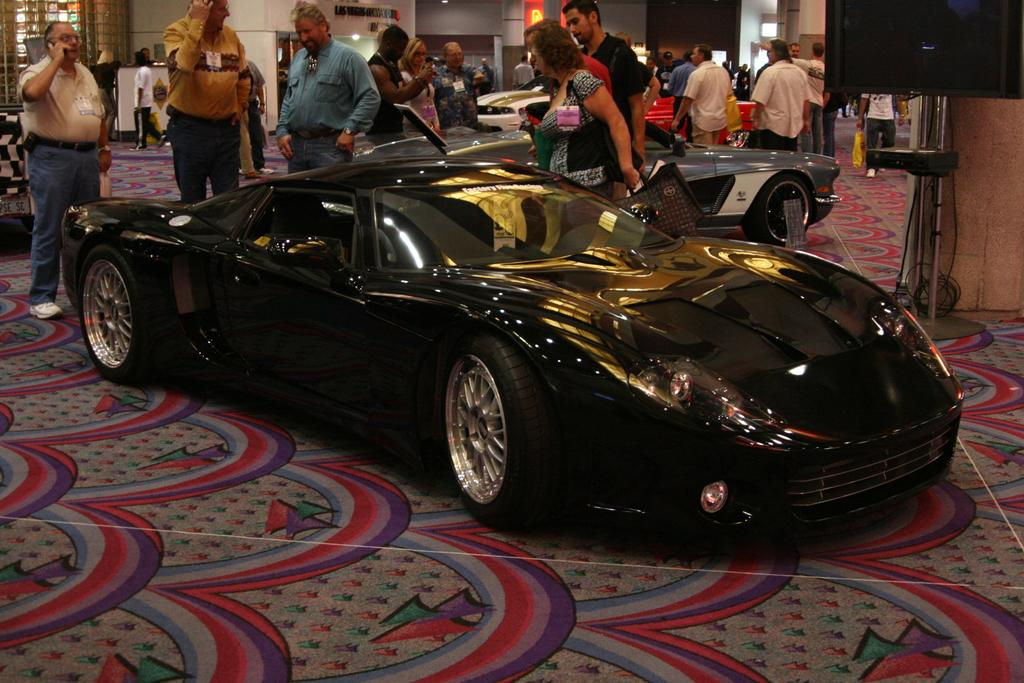What type of vehicles can be seen in the image? There are cars in the image. Who or what else is present in the image besides the cars? There are persons in the image. What can be seen on the floor in the image? The floor is visible in the image, and there is a carpet on the floor. What architectural features can be seen in the background of the image? There is a wall, a pillar, and lights in the background of the image. What might be used for displaying information or media in the image? There is a screen in the image. What type of tree can be seen growing in the image? There is no tree present in the image. How does the growth of the persons in the image compare to the growth of the cars? The persons and cars in the image are not growing, as they are stationary objects. 